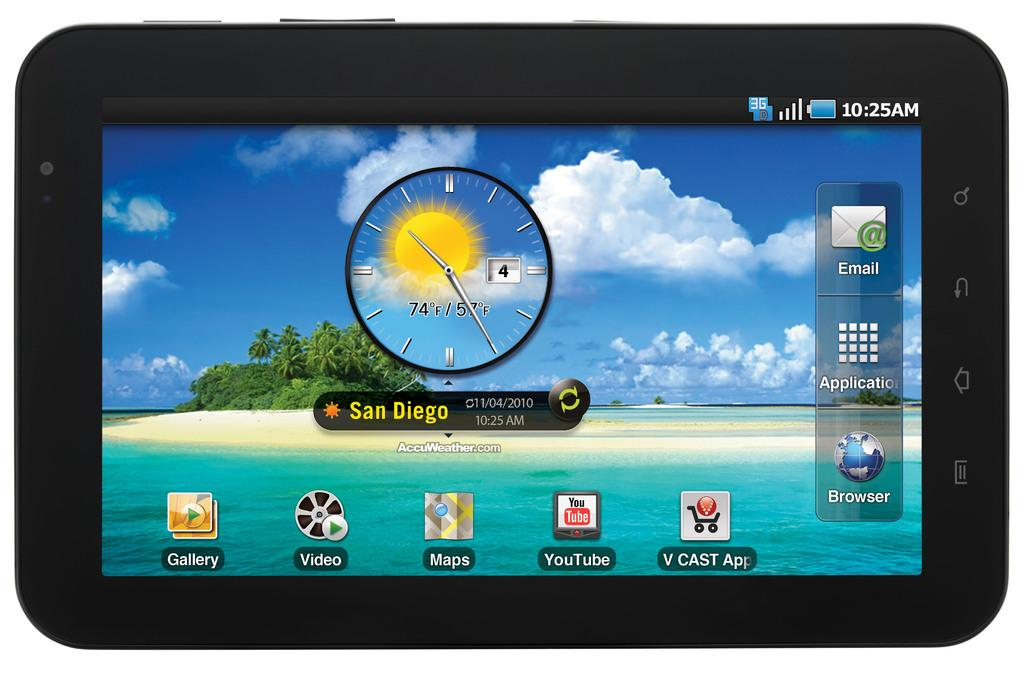<image>
Provide a brief description of the given image. the city of san diego which is on a screen 